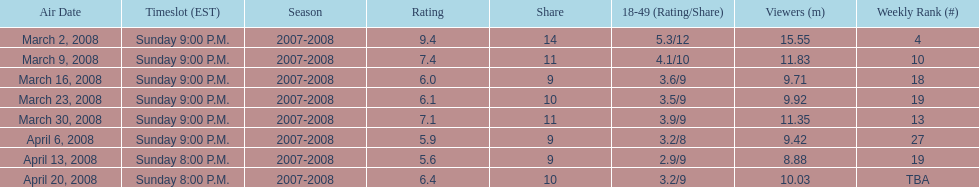What episode had the highest rating? March 2, 2008. 